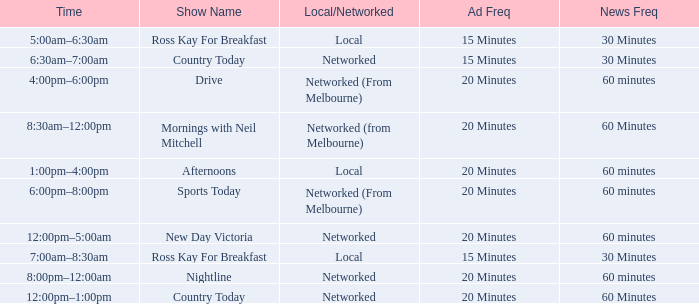What Time has a Show Name of mornings with neil mitchell? 8:30am–12:00pm. 